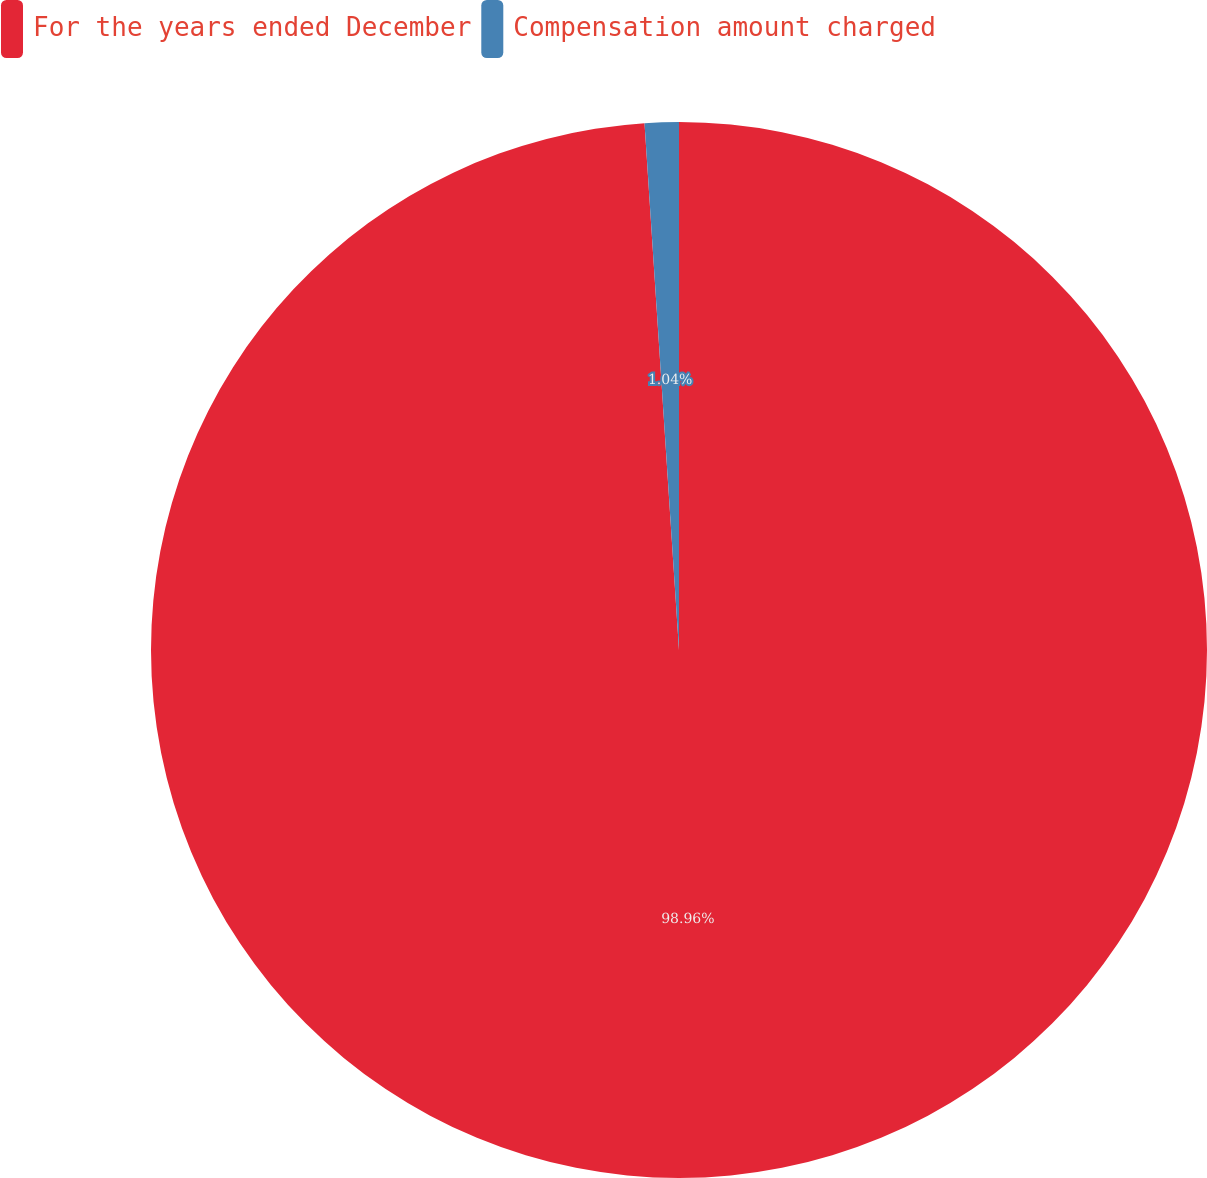Convert chart. <chart><loc_0><loc_0><loc_500><loc_500><pie_chart><fcel>For the years ended December<fcel>Compensation amount charged<nl><fcel>98.96%<fcel>1.04%<nl></chart> 